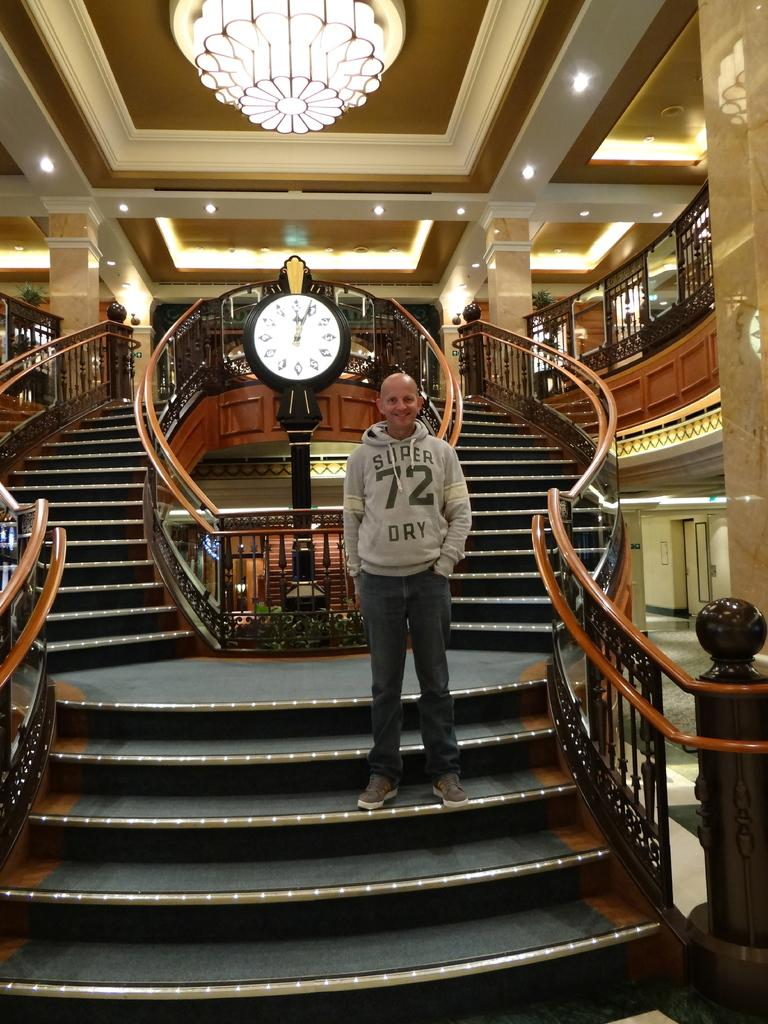<image>
Create a compact narrative representing the image presented. Standing on an amazing staircase the man wears a top saying 72. 